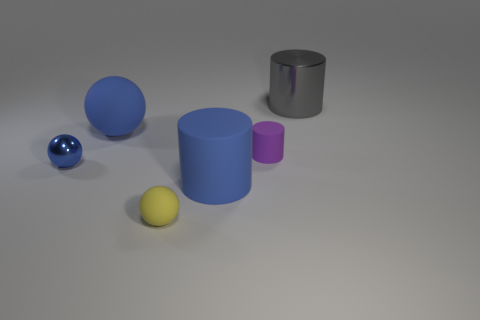Subtract all gray cylinders. How many cylinders are left? 2 Add 1 tiny blue rubber things. How many objects exist? 7 Subtract all yellow balls. How many balls are left? 2 Subtract 1 spheres. How many spheres are left? 2 Add 4 large gray metallic things. How many large gray metallic things exist? 5 Subtract 0 yellow cylinders. How many objects are left? 6 Subtract all yellow spheres. Subtract all purple cubes. How many spheres are left? 2 Subtract all red cylinders. How many green balls are left? 0 Subtract all large cyan metal spheres. Subtract all blue spheres. How many objects are left? 4 Add 4 tiny things. How many tiny things are left? 7 